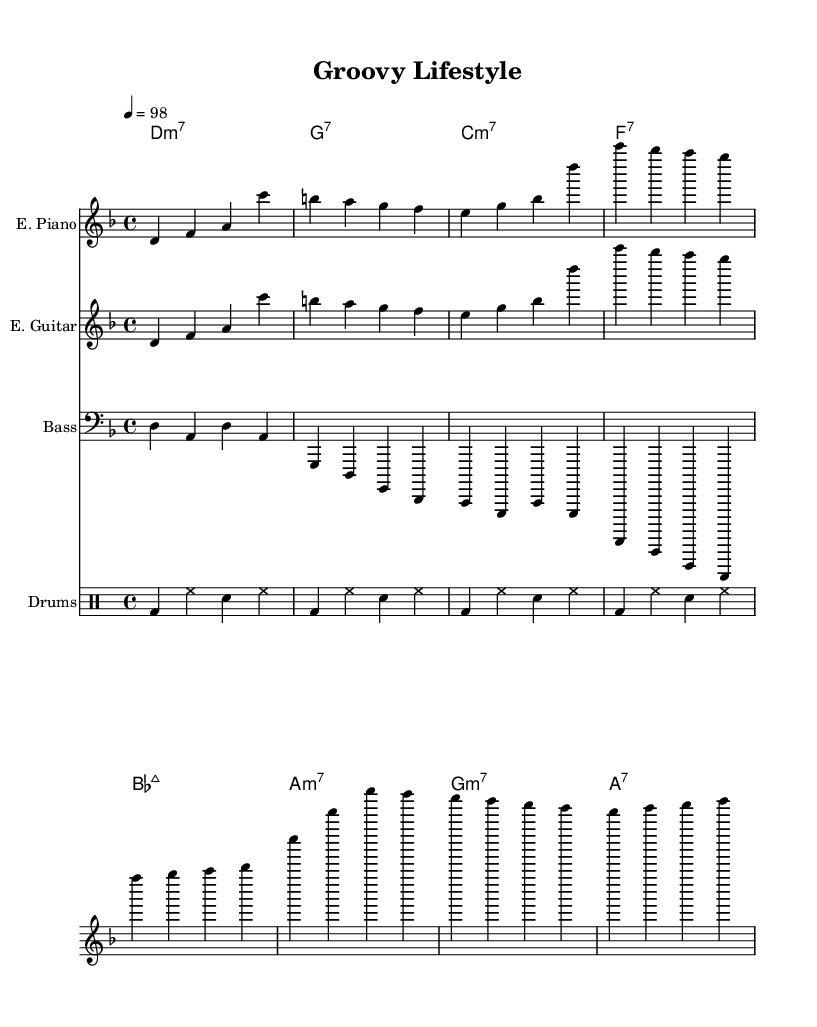What is the key signature of this music? The key signature is indicated by the notes and any sharps or flats present. Looking at the music, there are no sharps or flats, which means it is in D minor.
Answer: D minor What is the time signature of this piece? The time signature is found at the beginning of the score, usually noted as two numbers one above the other. Here, it shows 4/4, indicating four beats in each measure.
Answer: 4/4 What is the tempo mark for this composition? The tempo is indicated in the score, usually represented as a BPM (beats per minute) number. In this case, the tempo is marked as 4 = 98, indicating the speed of the piece.
Answer: 98 How many measures does the verse section have? By counting the measures in the verse melody of the electric piano (or any instrument), we can determine the number of measures. The verse melody has four measures.
Answer: 4 What chords are used in the chorus? To find the chorus chords, we look at the chord names section during the chorus melody. The chords indicated are B flat major 7, A minor 7, G minor 7, and A7, totaling four chords.
Answer: B flat major 7, A minor 7, G minor 7, A7 What type of groove is predominant in this funk piece? The groove in funk music typically consists of syncopated rhythms with a strong backbeat. Here, the drum pattern emphasizes a consistent bass drum (bd) and snare (sn) rhythm, creating that signature funky feel.
Answer: Funky groove What instrument is primarily playing the bass line? The bass line can be identified by looking at the staff labeled "Bass." Thus, the instrument that plays the bass line is the Bass Guitar.
Answer: Bass Guitar 